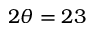Convert formula to latex. <formula><loc_0><loc_0><loc_500><loc_500>2 \theta = 2 3</formula> 